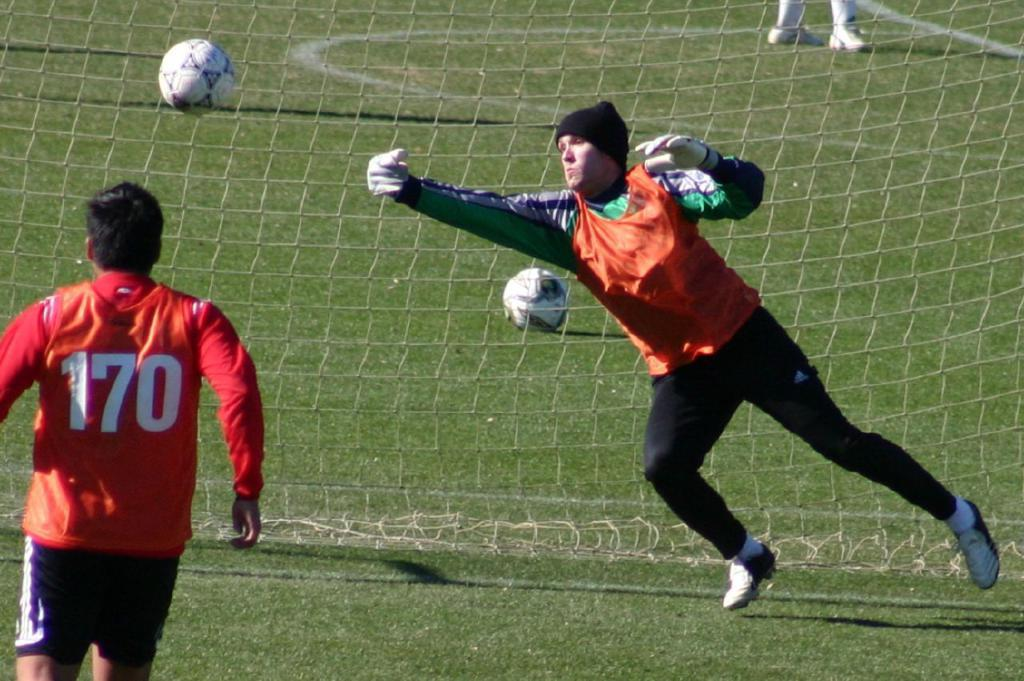How many people are in the image? There are two persons in the image. What are the persons doing in the image? The persons are playing football. Can you describe the clothing of the persons? The persons are wearing different color dresses. What can be seen in the background of the image? There are two balls and a net visible in the background of the image, as well as a person's legs. What type of zinc is being used to heat the system in the image? There is no mention of zinc, heat, or a system in the image; it features two people playing football. 